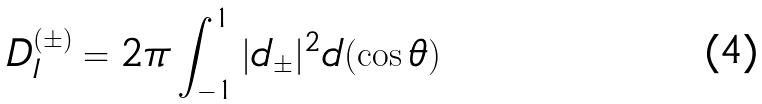Convert formula to latex. <formula><loc_0><loc_0><loc_500><loc_500>D ^ { ( \pm ) } _ { I } = 2 \pi \int ^ { 1 } _ { - 1 } | d _ { \pm } | ^ { 2 } d ( \cos \theta )</formula> 